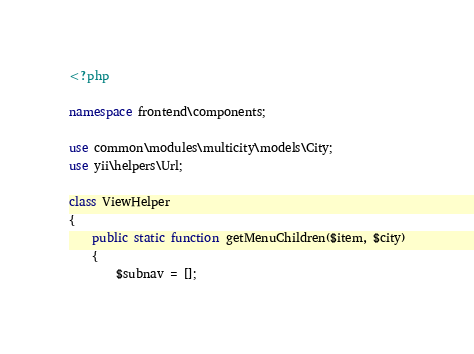Convert code to text. <code><loc_0><loc_0><loc_500><loc_500><_PHP_><?php

namespace frontend\components;

use common\modules\multicity\models\City;
use yii\helpers\Url;

class ViewHelper 
{
    public static function getMenuChildren($item, $city)
    {
        $subnav = [];</code> 